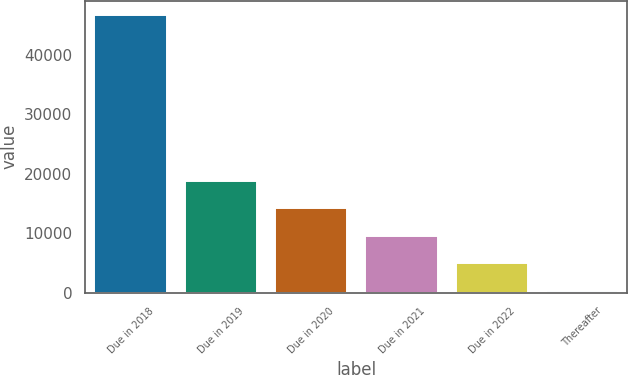<chart> <loc_0><loc_0><loc_500><loc_500><bar_chart><fcel>Due in 2018<fcel>Due in 2019<fcel>Due in 2020<fcel>Due in 2021<fcel>Due in 2022<fcel>Thereafter<nl><fcel>46774<fcel>18868<fcel>14217<fcel>9566<fcel>4915<fcel>264<nl></chart> 